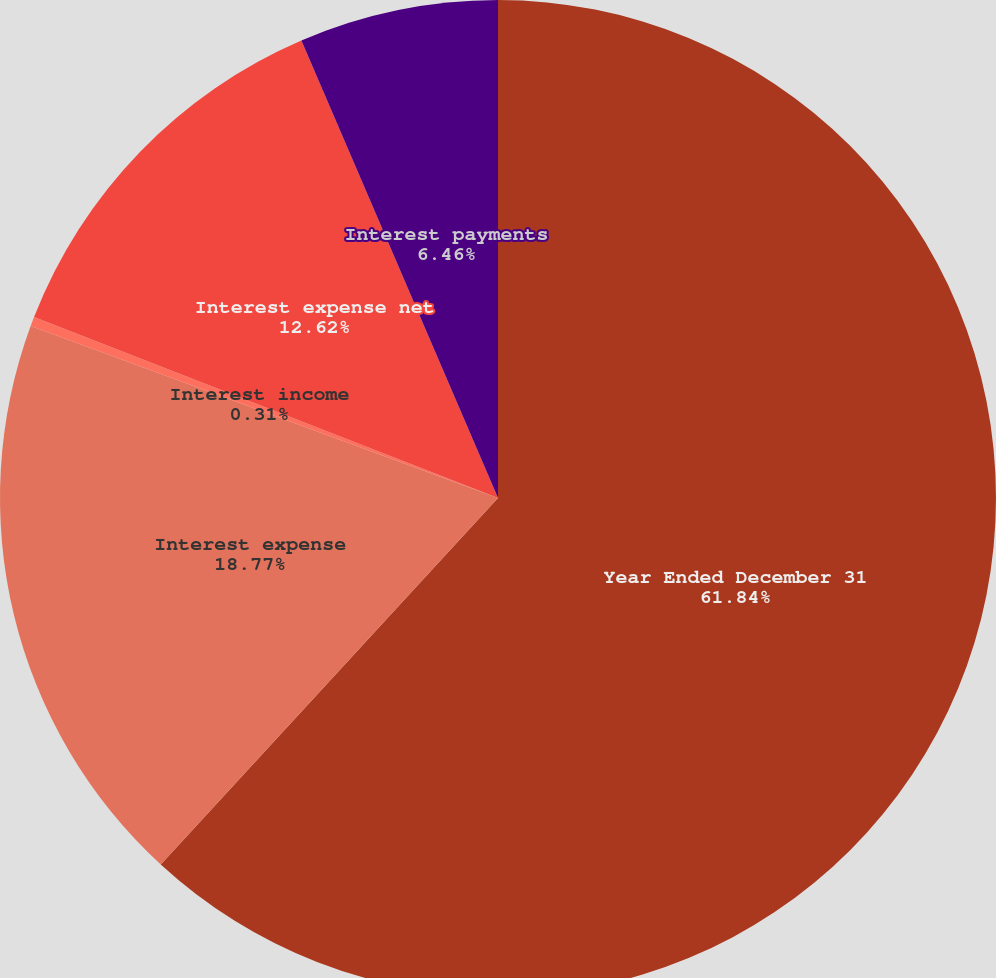<chart> <loc_0><loc_0><loc_500><loc_500><pie_chart><fcel>Year Ended December 31<fcel>Interest expense<fcel>Interest income<fcel>Interest expense net<fcel>Interest payments<nl><fcel>61.84%<fcel>18.77%<fcel>0.31%<fcel>12.62%<fcel>6.46%<nl></chart> 